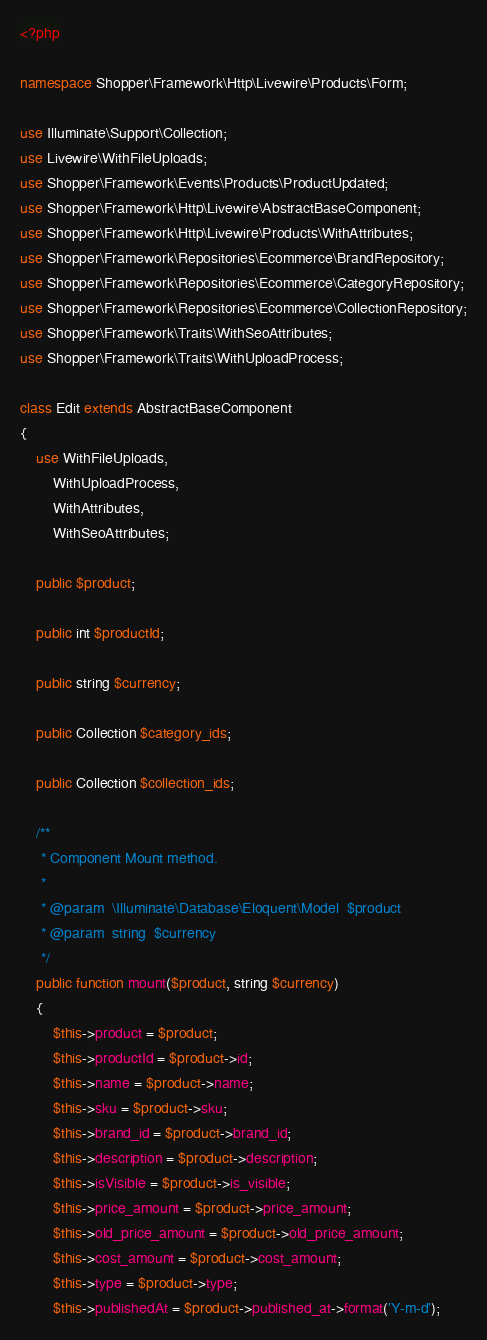<code> <loc_0><loc_0><loc_500><loc_500><_PHP_><?php

namespace Shopper\Framework\Http\Livewire\Products\Form;

use Illuminate\Support\Collection;
use Livewire\WithFileUploads;
use Shopper\Framework\Events\Products\ProductUpdated;
use Shopper\Framework\Http\Livewire\AbstractBaseComponent;
use Shopper\Framework\Http\Livewire\Products\WithAttributes;
use Shopper\Framework\Repositories\Ecommerce\BrandRepository;
use Shopper\Framework\Repositories\Ecommerce\CategoryRepository;
use Shopper\Framework\Repositories\Ecommerce\CollectionRepository;
use Shopper\Framework\Traits\WithSeoAttributes;
use Shopper\Framework\Traits\WithUploadProcess;

class Edit extends AbstractBaseComponent
{
    use WithFileUploads,
        WithUploadProcess,
        WithAttributes,
        WithSeoAttributes;

    public $product;

    public int $productId;

    public string $currency;

    public Collection $category_ids;

    public Collection $collection_ids;

    /**
     * Component Mount method.
     *
     * @param  \Illuminate\Database\Eloquent\Model  $product
     * @param  string  $currency
     */
    public function mount($product, string $currency)
    {
        $this->product = $product;
        $this->productId = $product->id;
        $this->name = $product->name;
        $this->sku = $product->sku;
        $this->brand_id = $product->brand_id;
        $this->description = $product->description;
        $this->isVisible = $product->is_visible;
        $this->price_amount = $product->price_amount;
        $this->old_price_amount = $product->old_price_amount;
        $this->cost_amount = $product->cost_amount;
        $this->type = $product->type;
        $this->publishedAt = $product->published_at->format('Y-m-d');</code> 